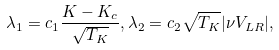<formula> <loc_0><loc_0><loc_500><loc_500>\lambda _ { 1 } = c _ { 1 } \frac { K - K _ { c } } { \sqrt { T _ { K } } } , \lambda _ { 2 } = c _ { 2 } \sqrt { T _ { K } } | \nu V _ { L R } | ,</formula> 